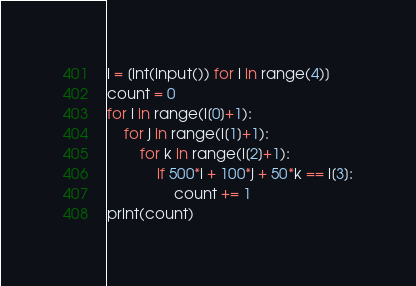<code> <loc_0><loc_0><loc_500><loc_500><_Python_>l = [int(input()) for i in range(4)]
count = 0
for i in range(l[0]+1):
    for j in range(l[1]+1):
        for k in range(l[2]+1):
            if 500*i + 100*j + 50*k == l[3]:
                count += 1
print(count)</code> 